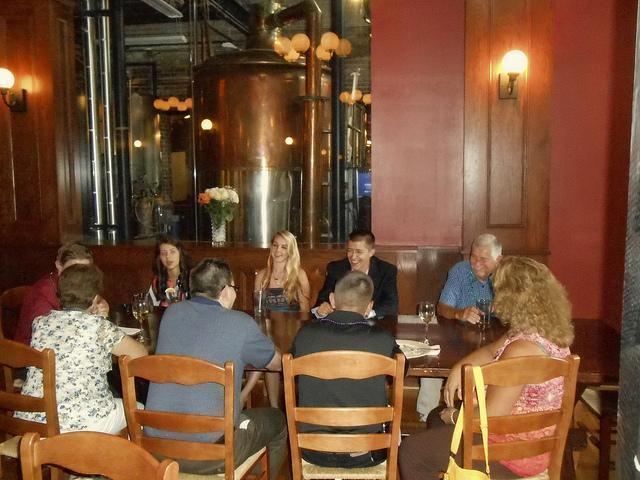What is the equipment in the background used for?
Select the correct answer and articulate reasoning with the following format: 'Answer: answer
Rationale: rationale.'
Options: Relaxation, heat, filtration, brewing. Answer: brewing.
Rationale: It's to brew assorted types of beer. 